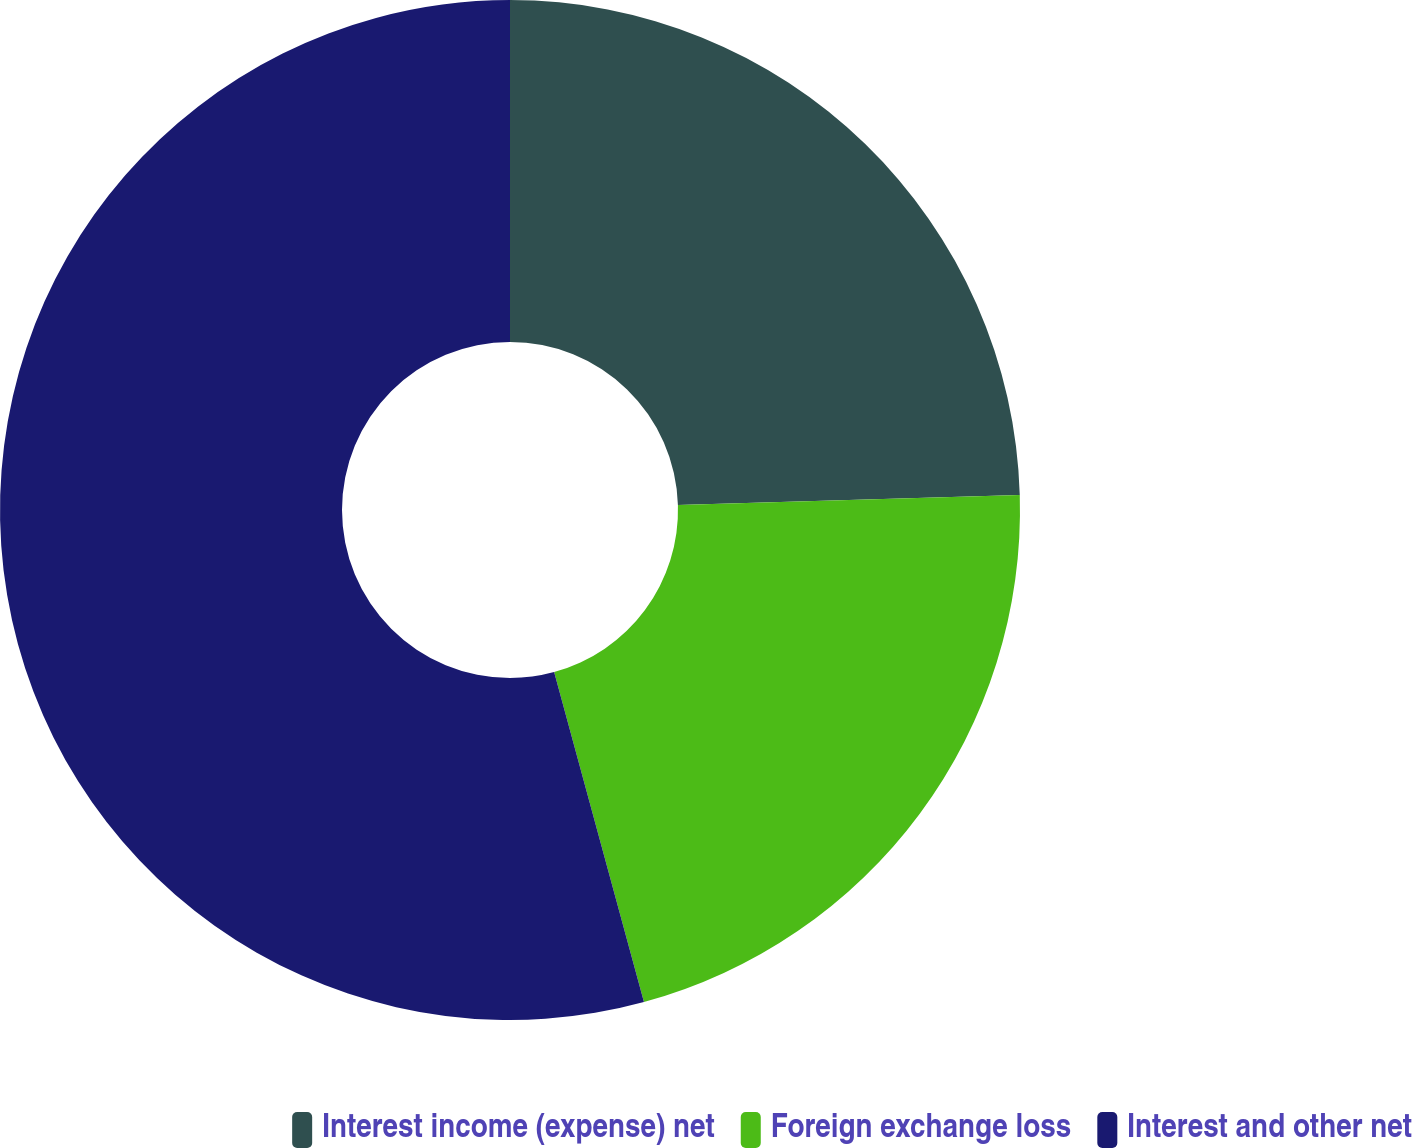<chart> <loc_0><loc_0><loc_500><loc_500><pie_chart><fcel>Interest income (expense) net<fcel>Foreign exchange loss<fcel>Interest and other net<nl><fcel>24.53%<fcel>21.24%<fcel>54.23%<nl></chart> 